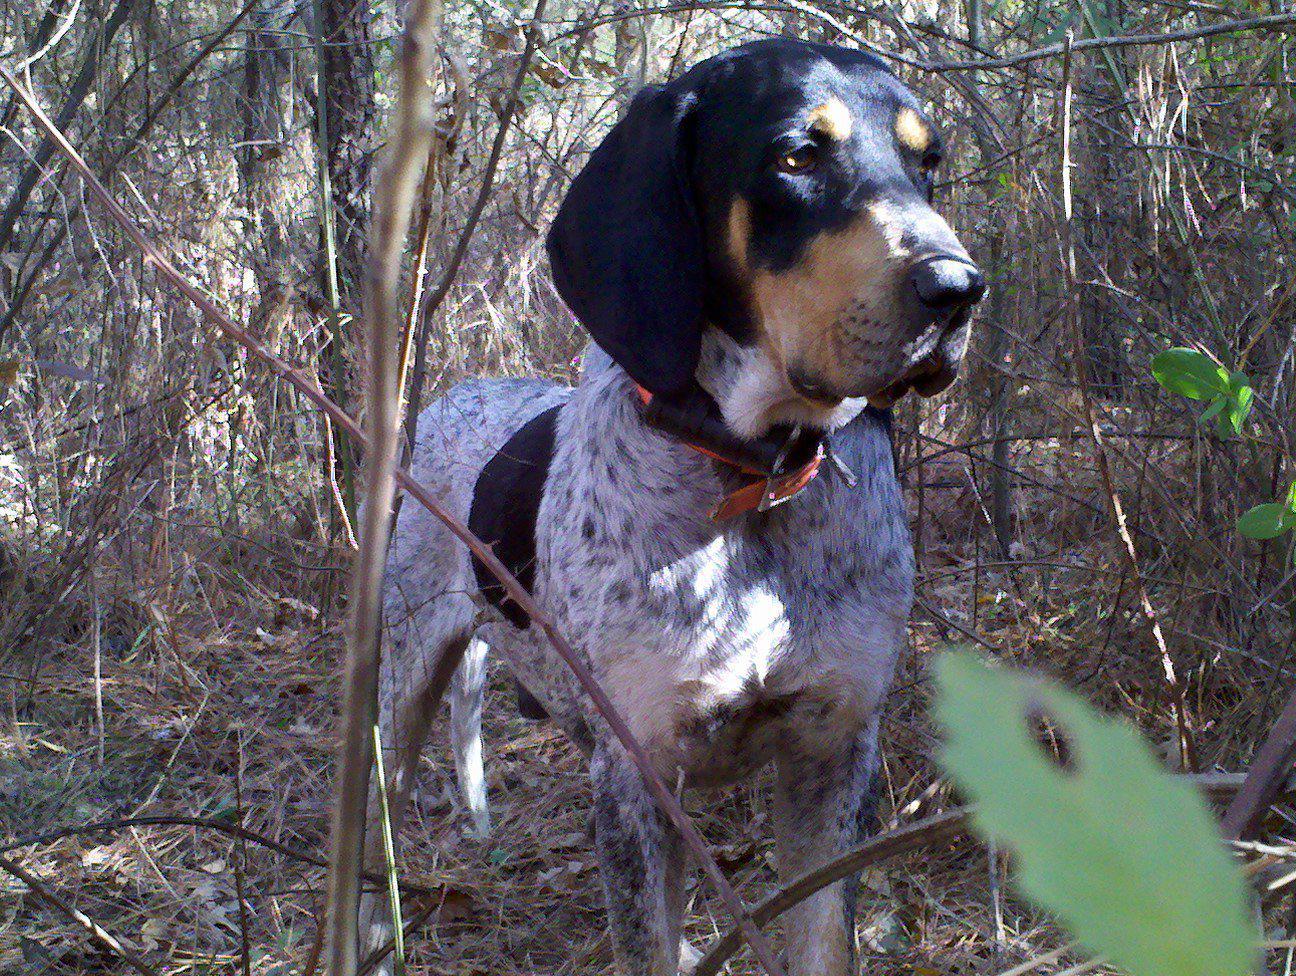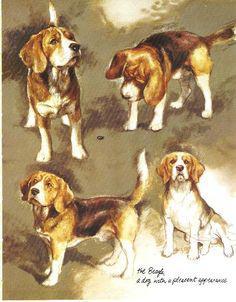The first image is the image on the left, the second image is the image on the right. For the images displayed, is the sentence "There is exactly one dog in one of the images." factually correct? Answer yes or no. Yes. 